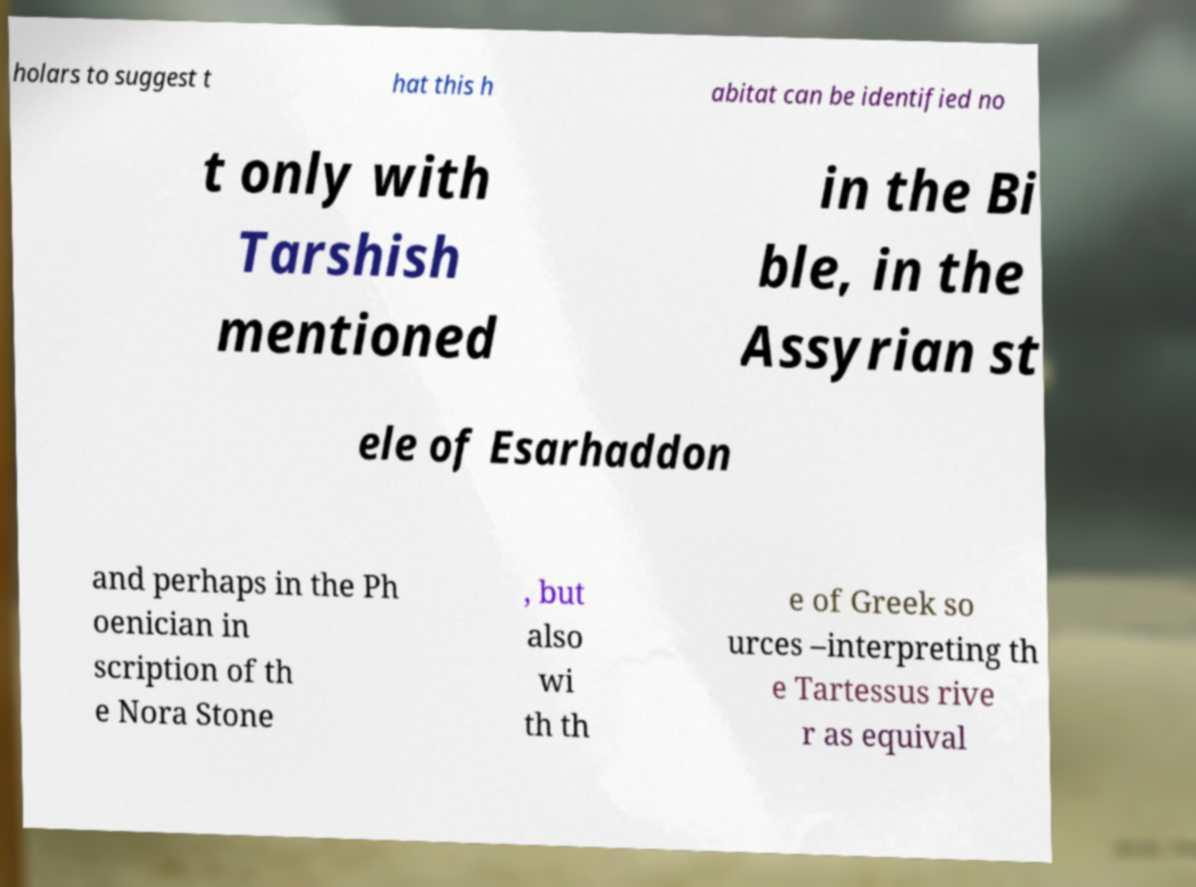There's text embedded in this image that I need extracted. Can you transcribe it verbatim? holars to suggest t hat this h abitat can be identified no t only with Tarshish mentioned in the Bi ble, in the Assyrian st ele of Esarhaddon and perhaps in the Ph oenician in scription of th e Nora Stone , but also wi th th e of Greek so urces –interpreting th e Tartessus rive r as equival 